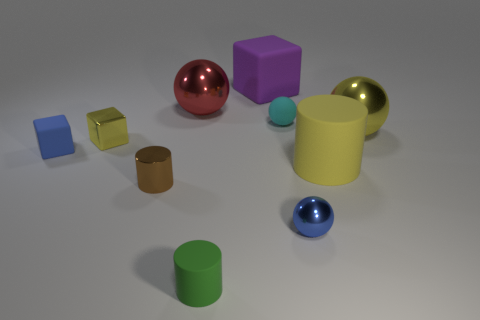Subtract all spheres. How many objects are left? 6 Add 9 small gray rubber spheres. How many small gray rubber spheres exist? 9 Subtract 0 red cylinders. How many objects are left? 10 Subtract all small cyan objects. Subtract all small brown cylinders. How many objects are left? 8 Add 3 tiny matte balls. How many tiny matte balls are left? 4 